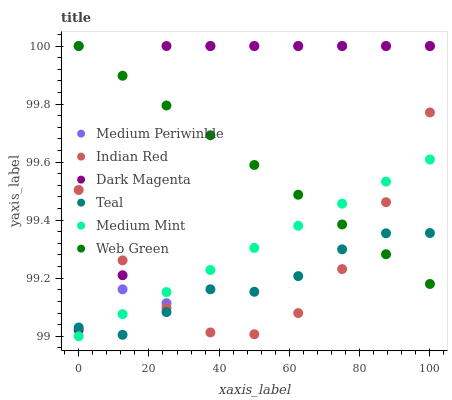Does Teal have the minimum area under the curve?
Answer yes or no. Yes. Does Dark Magenta have the maximum area under the curve?
Answer yes or no. Yes. Does Medium Periwinkle have the minimum area under the curve?
Answer yes or no. No. Does Medium Periwinkle have the maximum area under the curve?
Answer yes or no. No. Is Medium Mint the smoothest?
Answer yes or no. Yes. Is Medium Periwinkle the roughest?
Answer yes or no. Yes. Is Dark Magenta the smoothest?
Answer yes or no. No. Is Dark Magenta the roughest?
Answer yes or no. No. Does Medium Mint have the lowest value?
Answer yes or no. Yes. Does Dark Magenta have the lowest value?
Answer yes or no. No. Does Web Green have the highest value?
Answer yes or no. Yes. Does Teal have the highest value?
Answer yes or no. No. Is Medium Mint less than Dark Magenta?
Answer yes or no. Yes. Is Dark Magenta greater than Medium Mint?
Answer yes or no. Yes. Does Dark Magenta intersect Medium Periwinkle?
Answer yes or no. Yes. Is Dark Magenta less than Medium Periwinkle?
Answer yes or no. No. Is Dark Magenta greater than Medium Periwinkle?
Answer yes or no. No. Does Medium Mint intersect Dark Magenta?
Answer yes or no. No. 